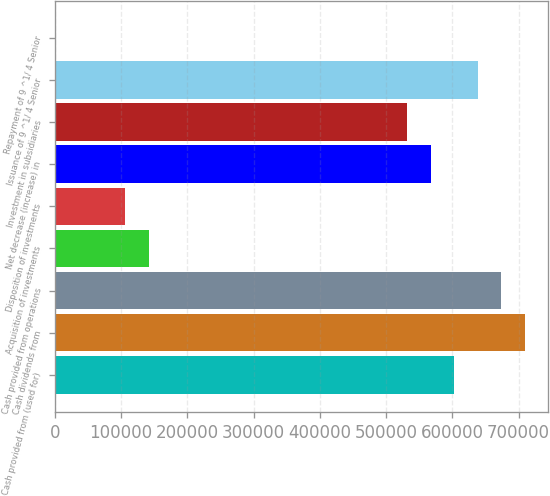<chart> <loc_0><loc_0><loc_500><loc_500><bar_chart><fcel>Cash provided from (used for)<fcel>Cash dividends from<fcel>Cash provided from operations<fcel>Acquisition of investments<fcel>Disposition of investments<fcel>Net decrease (increase) in<fcel>Investment in subsidiaries<fcel>Issuance of 9 ^1/ 4 Senior<fcel>Repayment of 9 ^1/ 4 Senior<nl><fcel>602981<fcel>709390<fcel>673920<fcel>141878<fcel>106409<fcel>567512<fcel>532042<fcel>638451<fcel>0.28<nl></chart> 